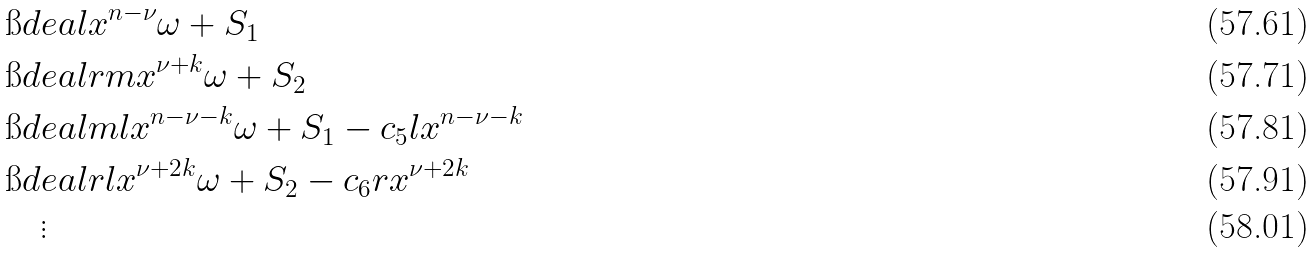Convert formula to latex. <formula><loc_0><loc_0><loc_500><loc_500>& \i d e a l { x ^ { n - \nu } } { \omega + S _ { 1 } } \\ & \i d e a l { r m x ^ { \nu + k } } { \omega + S _ { 2 } } \\ & \i d e a l { m l x ^ { n - \nu - k } } { \omega + S _ { 1 } - c _ { 5 } l x ^ { n - \nu - k } } \\ & \i d e a l { r l x ^ { \nu + 2 k } } { \omega + S _ { 2 } - c _ { 6 } r x ^ { \nu + 2 k } } \\ & \quad \vdots</formula> 